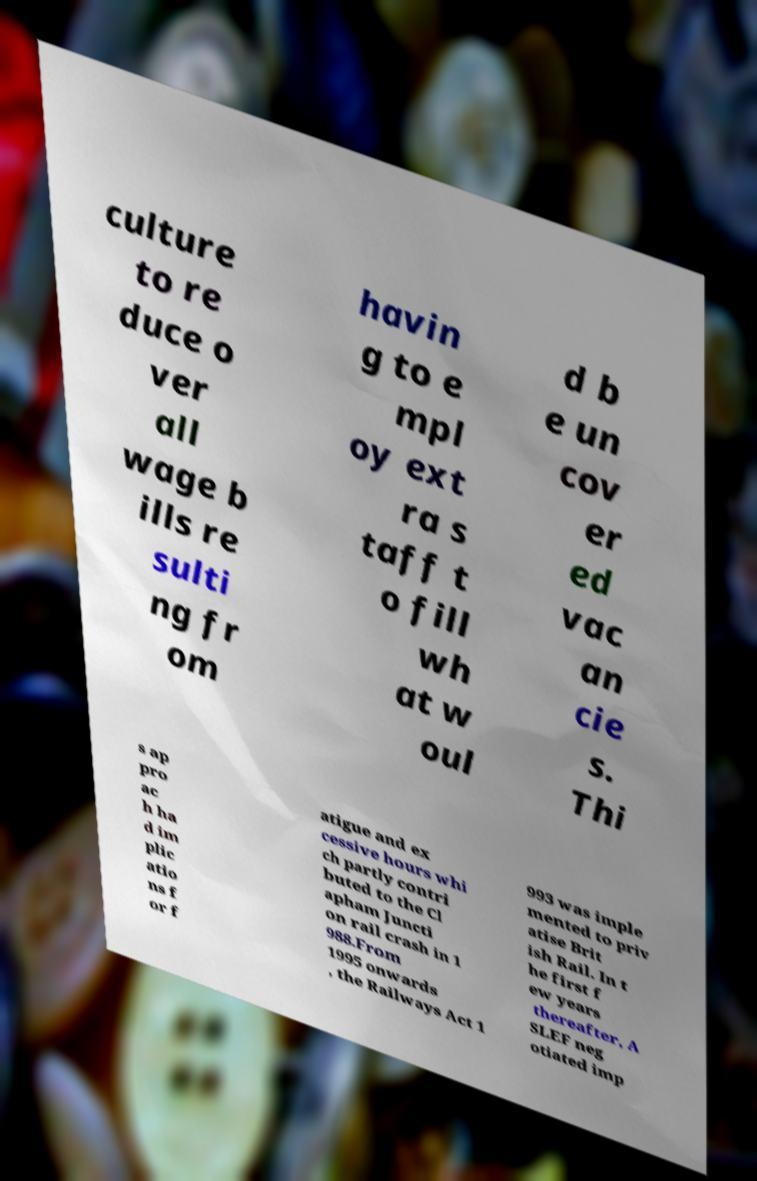Could you extract and type out the text from this image? culture to re duce o ver all wage b ills re sulti ng fr om havin g to e mpl oy ext ra s taff t o fill wh at w oul d b e un cov er ed vac an cie s. Thi s ap pro ac h ha d im plic atio ns f or f atigue and ex cessive hours whi ch partly contri buted to the Cl apham Juncti on rail crash in 1 988.From 1995 onwards , the Railways Act 1 993 was imple mented to priv atise Brit ish Rail. In t he first f ew years thereafter, A SLEF neg otiated imp 